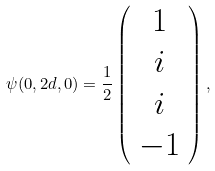<formula> <loc_0><loc_0><loc_500><loc_500>\psi ( 0 , 2 d , 0 ) = \frac { 1 } { 2 } \left ( \begin{array} { c } 1 \\ i \\ i \\ - 1 \end{array} \right ) ,</formula> 